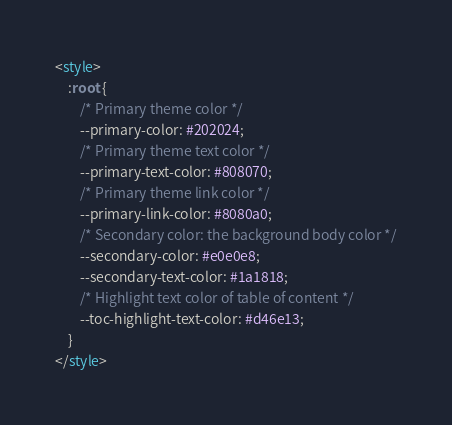<code> <loc_0><loc_0><loc_500><loc_500><_HTML_><style>
    :root {
        /* Primary theme color */
        --primary-color: #202024;
        /* Primary theme text color */
        --primary-text-color: #808070;
        /* Primary theme link color */
        --primary-link-color: #8080a0;
        /* Secondary color: the background body color */
        --secondary-color: #e0e0e8;
        --secondary-text-color: #1a1818;
        /* Highlight text color of table of content */
        --toc-highlight-text-color: #d46e13;
    }
</style></code> 